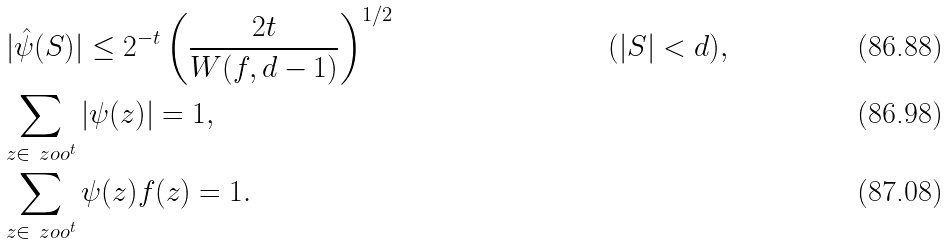Convert formula to latex. <formula><loc_0><loc_0><loc_500><loc_500>& \, | \hat { \psi } ( S ) | \leq 2 ^ { - t } \left ( \frac { 2 t } { W ( f , d - 1 ) } \right ) ^ { 1 / 2 } & & ( | S | < d ) , \\ & \sum _ { z \in \ z o o ^ { t } } | \psi ( z ) | = 1 , \\ & \sum _ { z \in \ z o o ^ { t } } \psi ( z ) f ( z ) = 1 .</formula> 